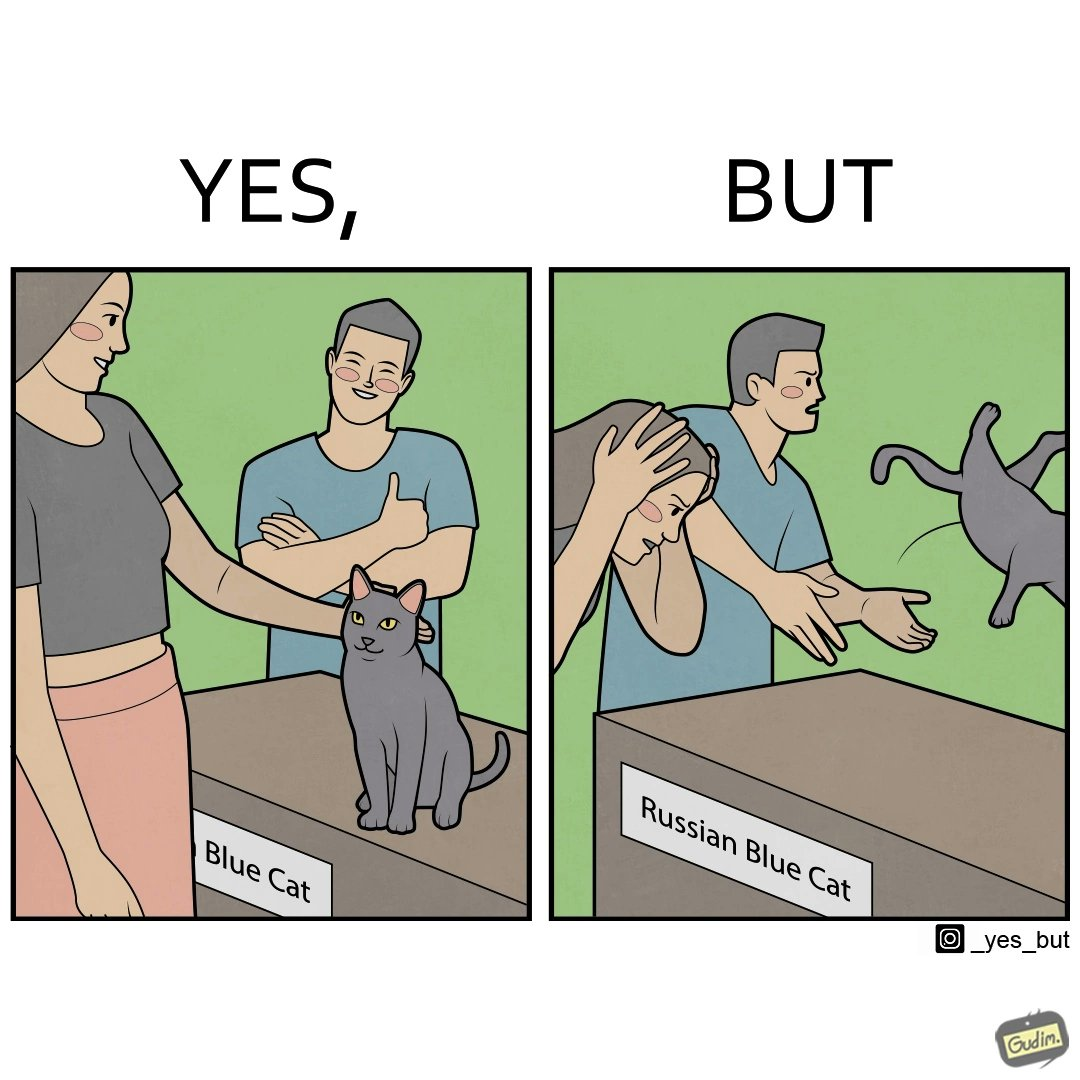What is shown in the left half versus the right half of this image? In the left part of the image: two happy people, where one of them is petting a cat sitting on a table, with a label "Blue Cat" written on the tabel. In the right part of the image: a worried person with hands on her head looking at a table with the label "Russian Blue Cat", while another angry person seems to be throwing away a cat. 